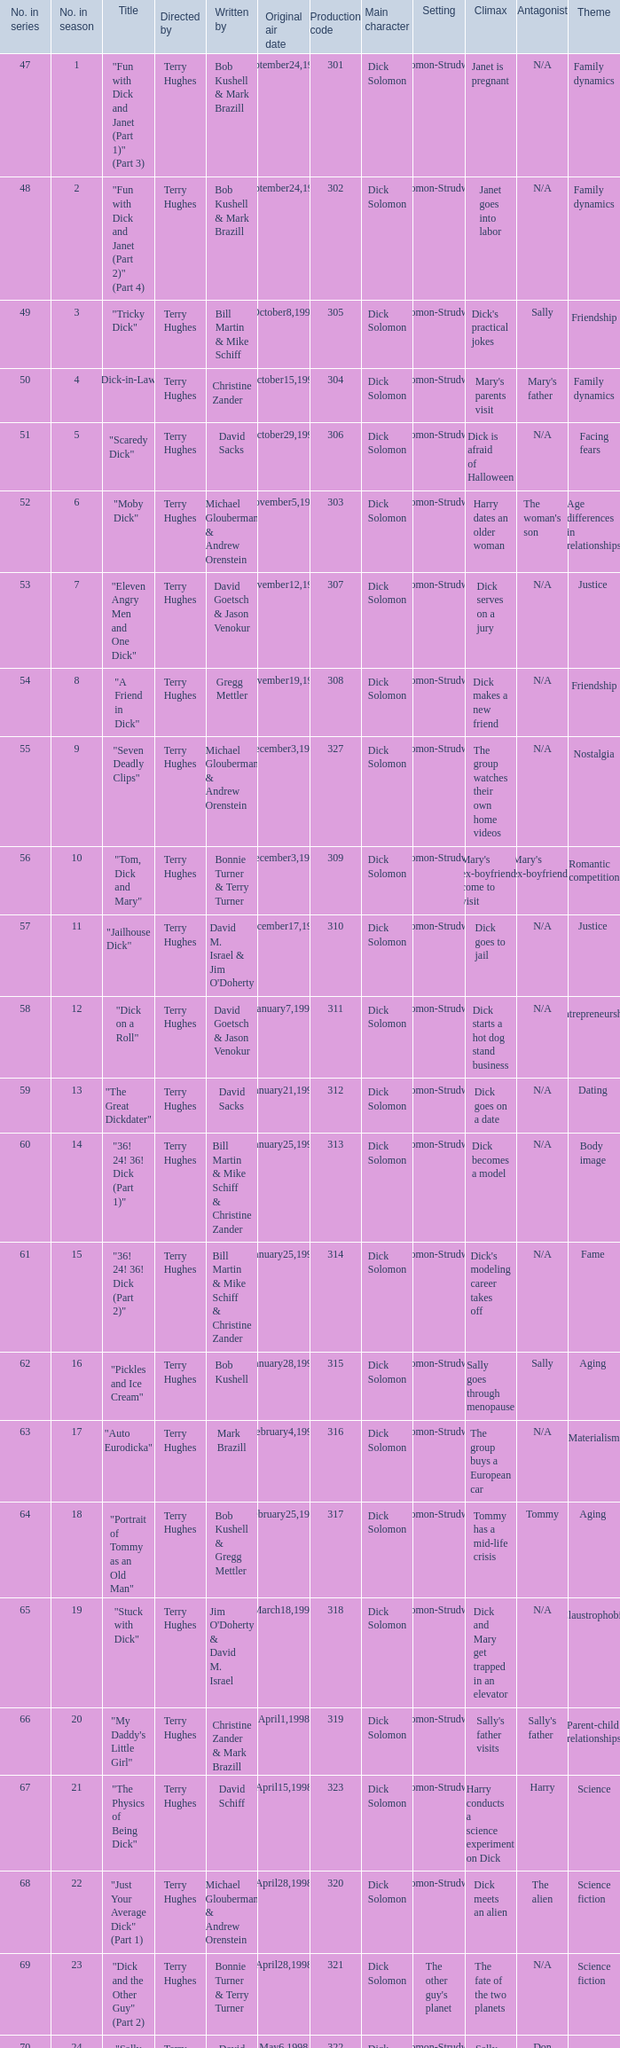What is the original air date of the episode with production code is 319? April1,1998. 